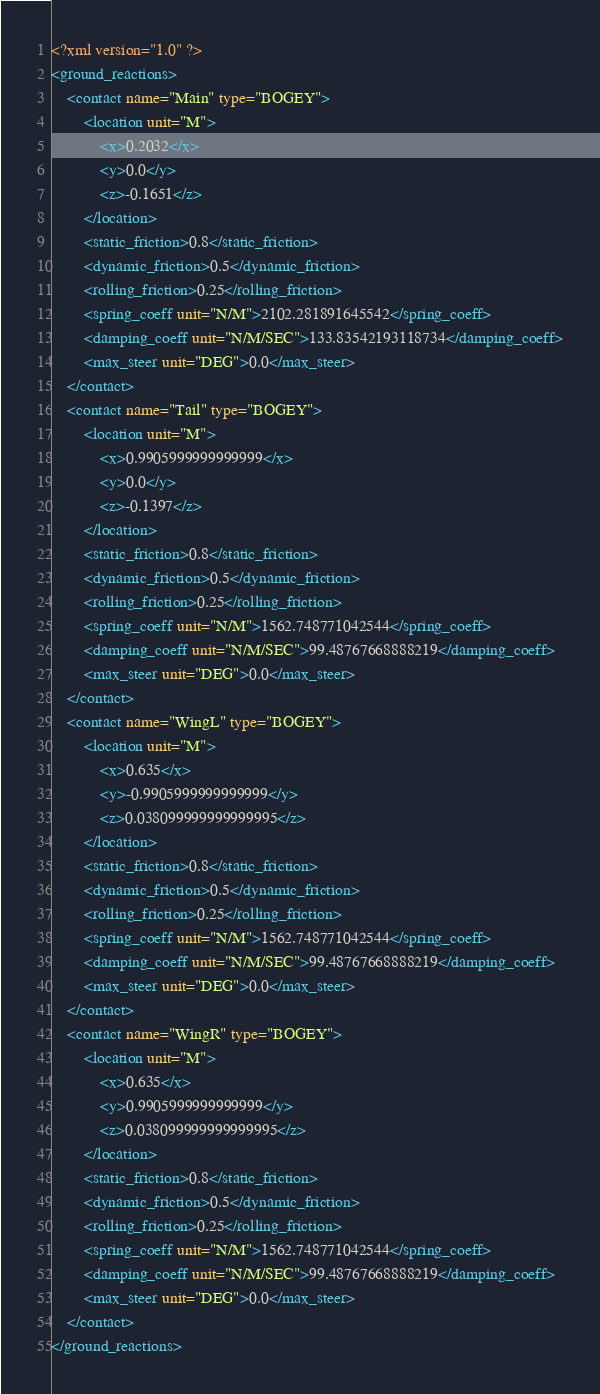Convert code to text. <code><loc_0><loc_0><loc_500><loc_500><_XML_><?xml version="1.0" ?>
<ground_reactions>
    <contact name="Main" type="BOGEY">
        <location unit="M">
            <x>0.2032</x>
            <y>0.0</y>
            <z>-0.1651</z>
        </location>
        <static_friction>0.8</static_friction>
        <dynamic_friction>0.5</dynamic_friction>
        <rolling_friction>0.25</rolling_friction>
        <spring_coeff unit="N/M">2102.281891645542</spring_coeff>
        <damping_coeff unit="N/M/SEC">133.83542193118734</damping_coeff>
        <max_steer unit="DEG">0.0</max_steer>
    </contact>
    <contact name="Tail" type="BOGEY">
        <location unit="M">
            <x>0.9905999999999999</x>
            <y>0.0</y>
            <z>-0.1397</z>
        </location>
        <static_friction>0.8</static_friction>
        <dynamic_friction>0.5</dynamic_friction>
        <rolling_friction>0.25</rolling_friction>
        <spring_coeff unit="N/M">1562.748771042544</spring_coeff>
        <damping_coeff unit="N/M/SEC">99.48767668888219</damping_coeff>
        <max_steer unit="DEG">0.0</max_steer>
    </contact>
    <contact name="WingL" type="BOGEY">
        <location unit="M">
            <x>0.635</x>
            <y>-0.9905999999999999</y>
            <z>0.038099999999999995</z>
        </location>
        <static_friction>0.8</static_friction>
        <dynamic_friction>0.5</dynamic_friction>
        <rolling_friction>0.25</rolling_friction>
        <spring_coeff unit="N/M">1562.748771042544</spring_coeff>
        <damping_coeff unit="N/M/SEC">99.48767668888219</damping_coeff>
        <max_steer unit="DEG">0.0</max_steer>
    </contact>
    <contact name="WingR" type="BOGEY">
        <location unit="M">
            <x>0.635</x>
            <y>0.9905999999999999</y>
            <z>0.038099999999999995</z>
        </location>
        <static_friction>0.8</static_friction>
        <dynamic_friction>0.5</dynamic_friction>
        <rolling_friction>0.25</rolling_friction>
        <spring_coeff unit="N/M">1562.748771042544</spring_coeff>
        <damping_coeff unit="N/M/SEC">99.48767668888219</damping_coeff>
        <max_steer unit="DEG">0.0</max_steer>
    </contact>
</ground_reactions>
</code> 